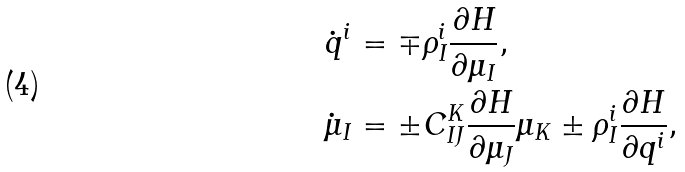Convert formula to latex. <formula><loc_0><loc_0><loc_500><loc_500>\dot { q } ^ { i } & = \mp \rho ^ { i } _ { I } \frac { \partial H } { \partial \mu _ { I } } , \\ \dot { \mu } _ { I } & = \pm C _ { I J } ^ { K } \frac { \partial H } { \partial \mu _ { J } } \mu _ { K } \pm \rho ^ { i } _ { I } \frac { \partial H } { \partial q ^ { i } } ,</formula> 